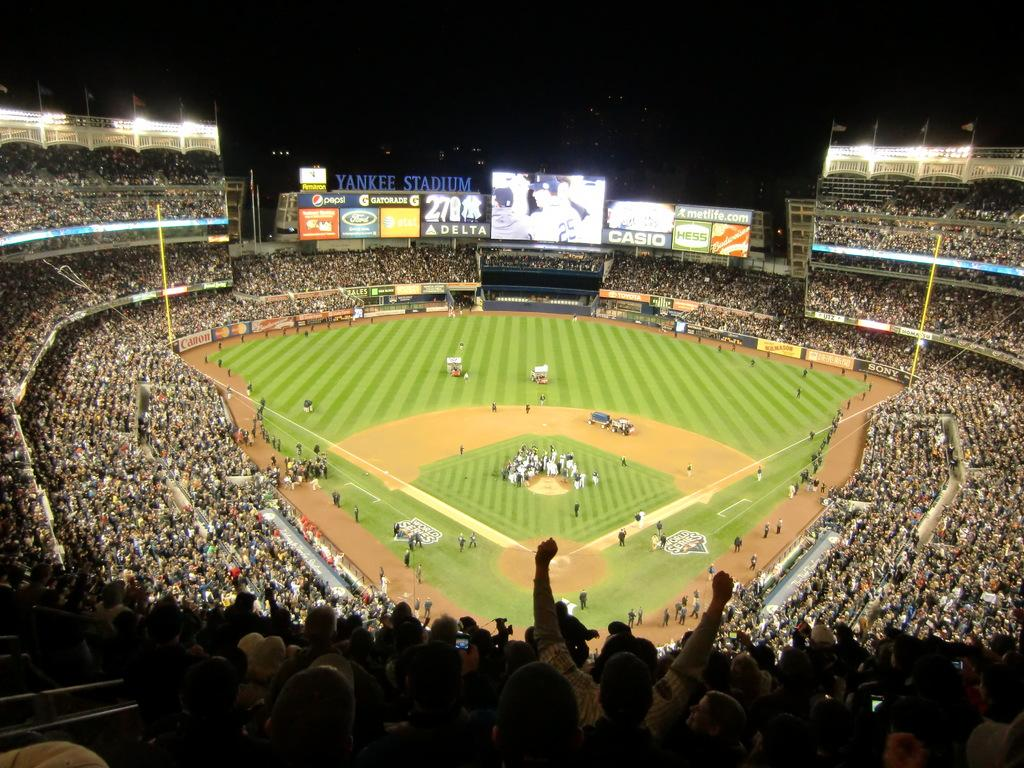<image>
Share a concise interpretation of the image provided. Huge blue lettering identifies a crowded sports arena as Yankee Stadium. 